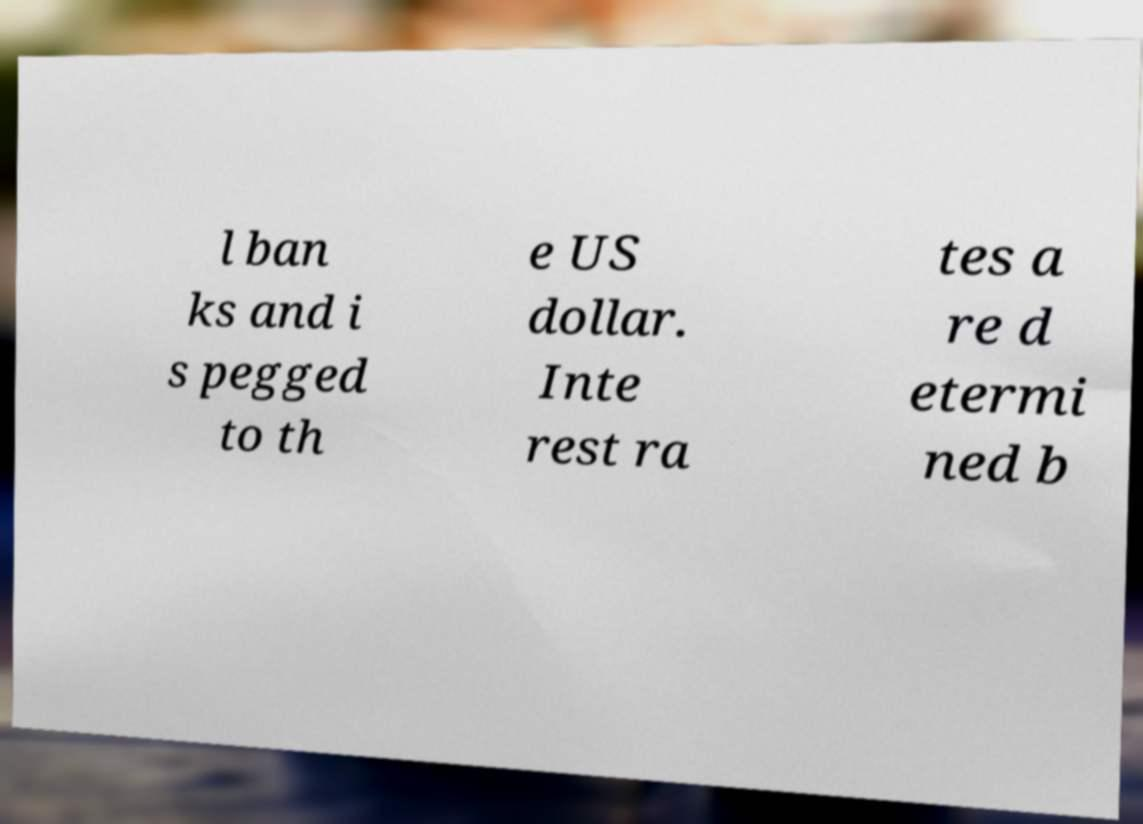For documentation purposes, I need the text within this image transcribed. Could you provide that? l ban ks and i s pegged to th e US dollar. Inte rest ra tes a re d etermi ned b 